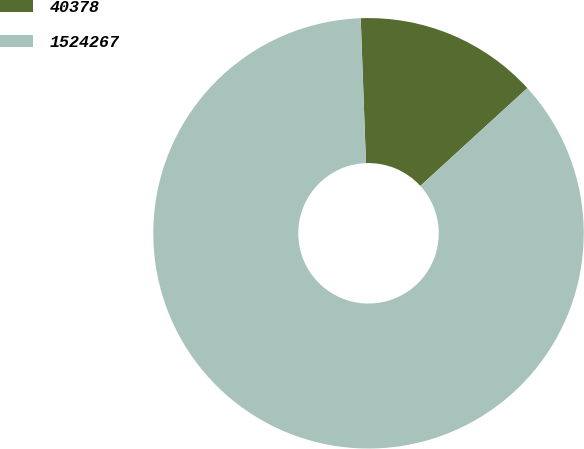<chart> <loc_0><loc_0><loc_500><loc_500><pie_chart><fcel>40378<fcel>1524267<nl><fcel>13.79%<fcel>86.21%<nl></chart> 